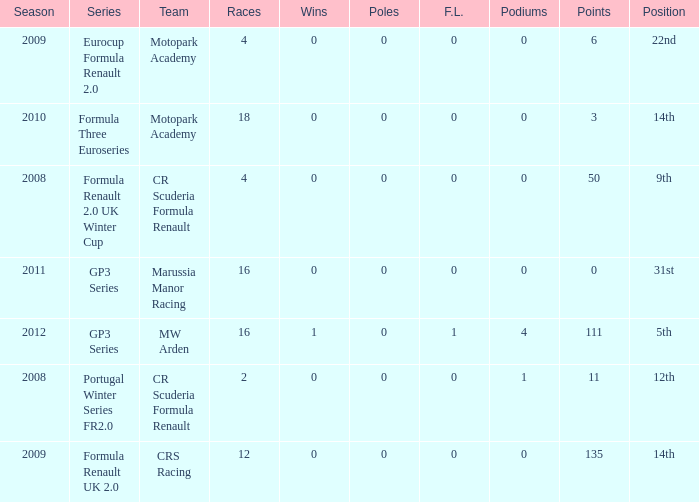How many F.L. are listed for Formula Three Euroseries? 1.0. 